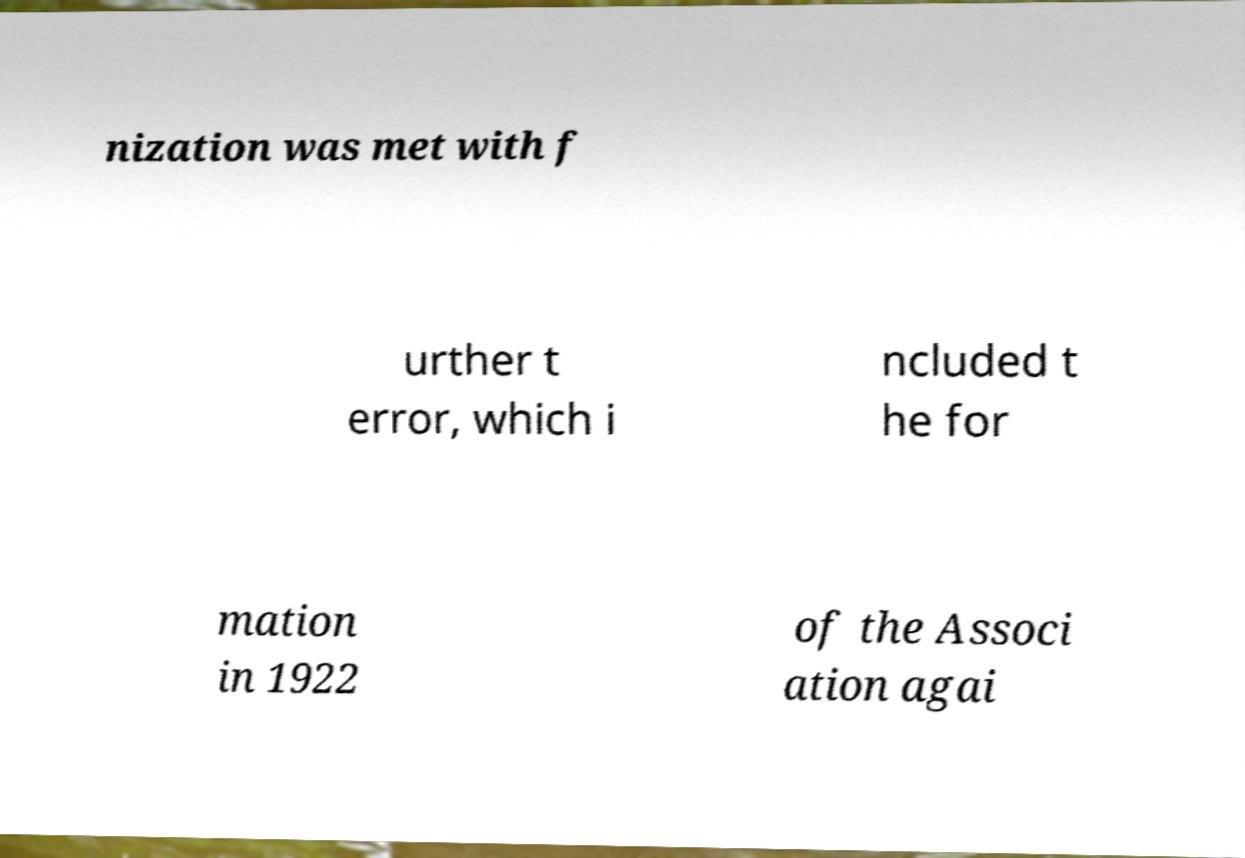Could you extract and type out the text from this image? nization was met with f urther t error, which i ncluded t he for mation in 1922 of the Associ ation agai 